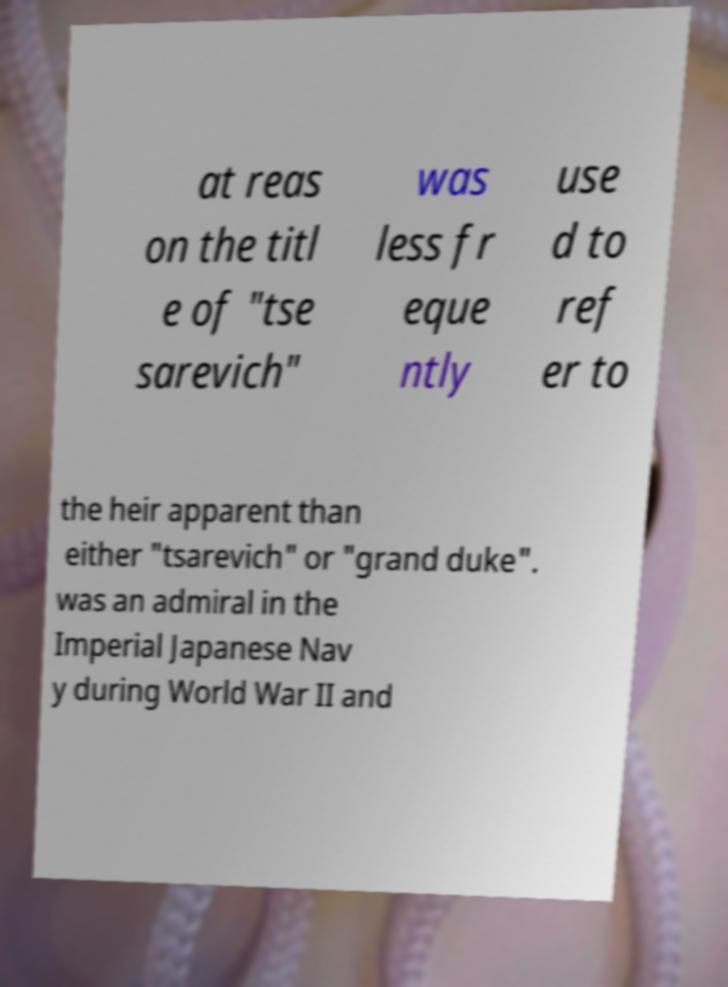I need the written content from this picture converted into text. Can you do that? at reas on the titl e of "tse sarevich" was less fr eque ntly use d to ref er to the heir apparent than either "tsarevich" or "grand duke". was an admiral in the Imperial Japanese Nav y during World War II and 